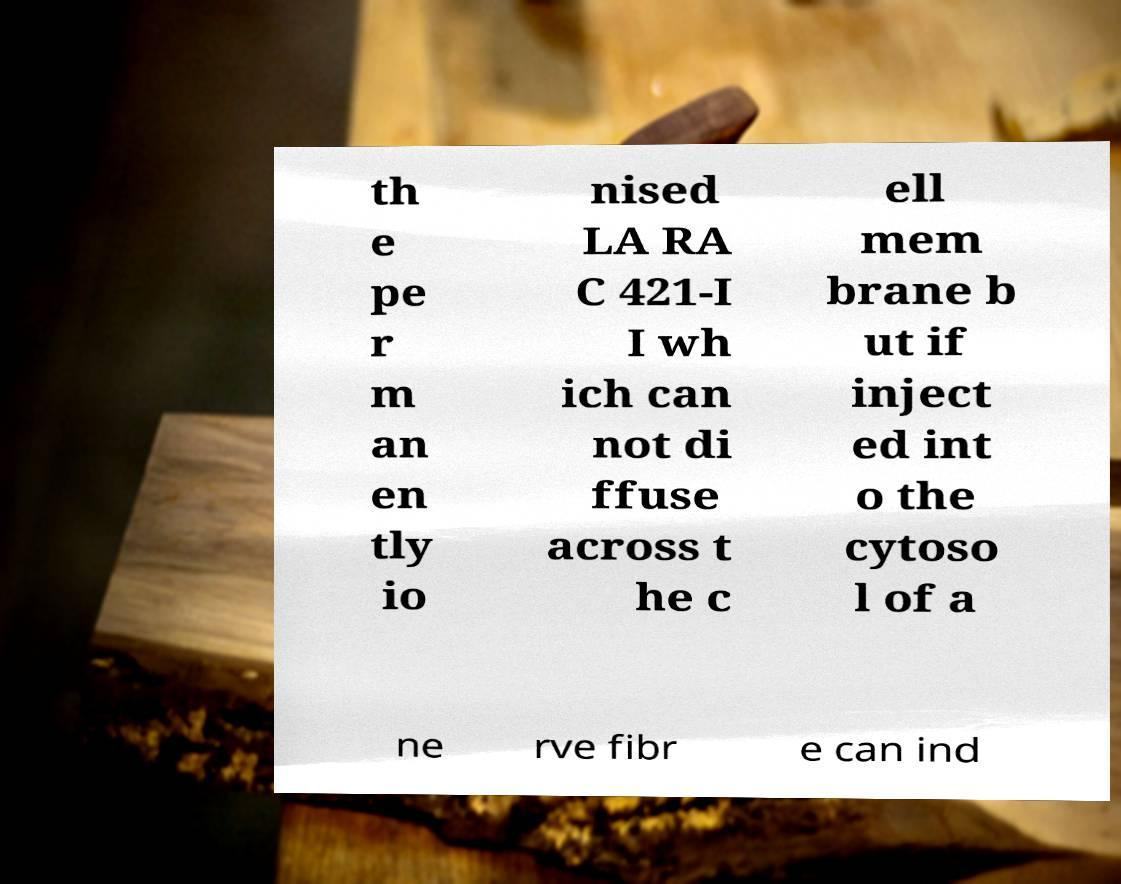Could you assist in decoding the text presented in this image and type it out clearly? th e pe r m an en tly io nised LA RA C 421-I I wh ich can not di ffuse across t he c ell mem brane b ut if inject ed int o the cytoso l of a ne rve fibr e can ind 